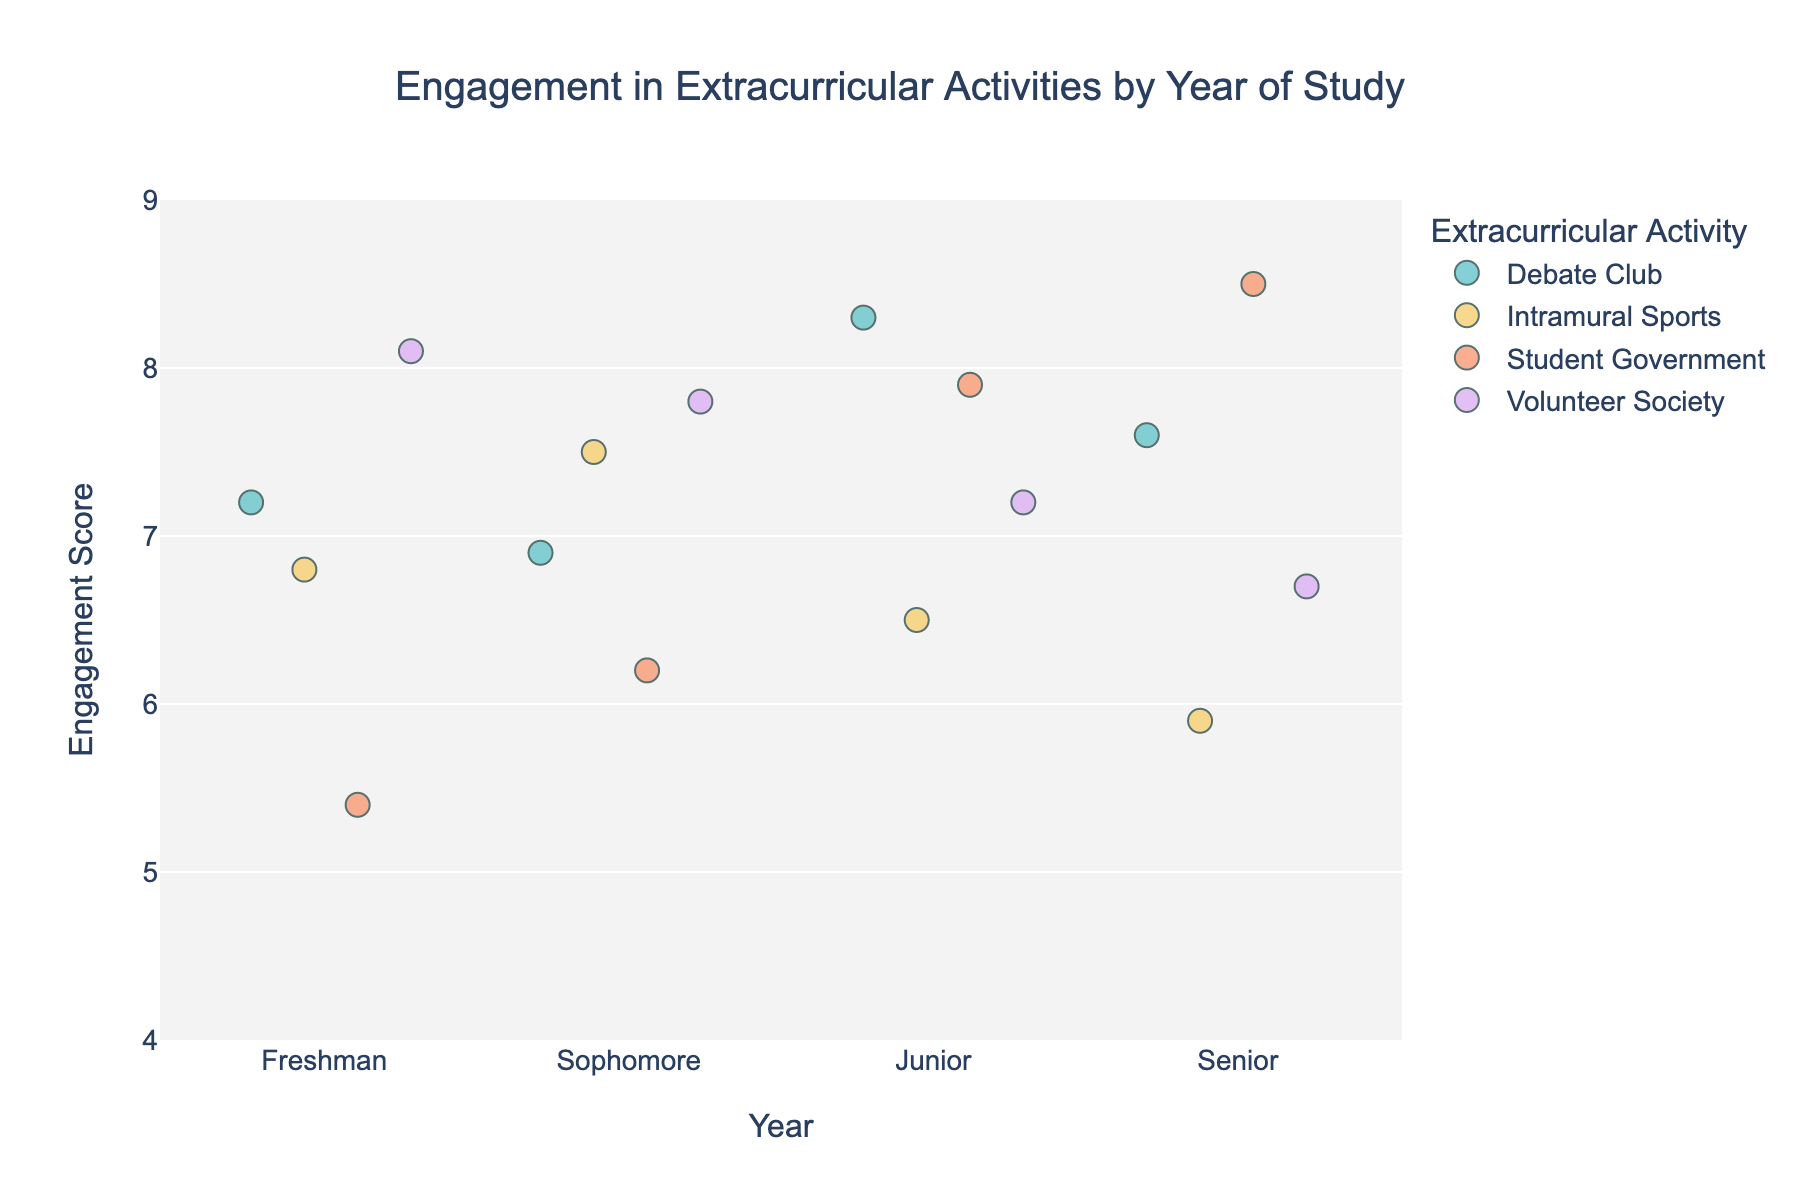What is the title of the strip plot? The title is usually placed at the top of the plot to indicate what the data visualization represents. In this case, it mentions the relationship and distribution of engagement in extracurricular activities among undergraduates by year of study.
Answer: Engagement in Extracurricular Activities by Year of Study What is the range of the y-axis representing engagement scores? The y-axis displays the range of engagement scores, which helps to understand the distribution and intensity of engagement. Checking the axis, it is seen that engagement scores range from a minimum to a maximum value.
Answer: 4 to 9 What color represents the "Volunteer Society" activity in the plot? Each activity is differentiated by a unique color according to the legend. By identifying the color corresponding to "Volunteer Society" in the legend, we can distinguish its data points in the plot.
Answer: A pastel color associated with "Volunteer Society" (exact appearance depends on the color scheme in the plot) Which year of study has the highest engagement score for "Student Government"? Looking at the spread of engagement scores by activities for each year, we identify the year where "Student Government" has its single highest score. This involves finding the peak point for "Student Government".
Answer: Senior What is the average engagement score for "Debate Club" across all years? We sum up the engagement scores for "Debate Club" across all years and divide by the number of observations to find the average. The scores are 7.2, 6.9, 8.3, and 7.6.
Answer: (7.2 + 6.9 + 8.3 + 7.6) / 4 = 7.5 How does the engagement in "Intramural Sports" compare between Sophomores and Seniors? We compare the score values for "Intramural Sports" between these two cohorts. The scores are 7.5 for Sophomores and 5.9 for Seniors, determining whether one is greater or lesser than the other.
Answer: Sophomores have higher engagement Which extracurricular activity has the most consistent engagement scores regardless of the year of study? Consistency can be observed through the spread of engagement scores for each activity. Among the activities, we check which one has the least variance or closely clustered data points across different years.
Answer: Volunteer Society has fairly consistent scores around 7-8 How many data points are there for each year of study? Counting the dots or data points for each year of study, where these points represent the engagement scores for different activities within that year. Confirm that each year has an equal number of activities.
Answer: 4 data points per year Which year has the lowest overall engagement scores? By examining the distribution of data points vertically on the y-axis, determine which year has the lower cluster of scores.
Answer: Senior (noting lower scores in activities like Intramural Sports) Are there any noticeable outliers in the engagement scores? If so, in which activities and years? Outliers are data points that stand out significantly from others, usually the highest or lowest points. By identifying them visually, we can point out which specific activity and year they belong to.
Answer: Freshman Volunteer Society (8.1) and Senior Student Government (8.5) are higher outliers 